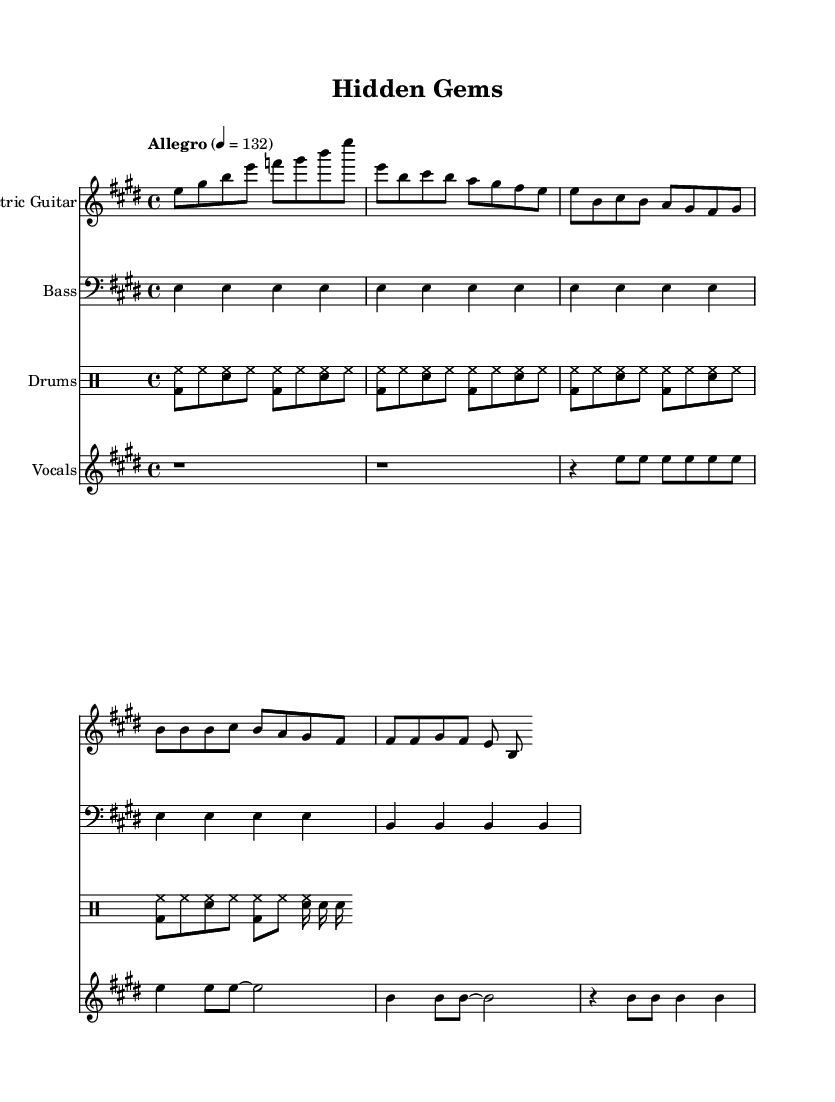What is the key signature of this music? The key signature is E major, which has four sharps (F#, C#, G#, D#). This is indicated at the beginning of the staff in the key signature section.
Answer: E major What is the time signature of this music? The time signature is 4/4, which is indicated at the beginning of the music. This means there are four beats per measure and the quarter note gets one beat.
Answer: 4/4 What is the tempo marking for this piece? The tempo marking is "Allegro" with a tempo of quarter note = 132, which indicates a fast and lively pace. This is clearly stated above the staff.
Answer: Allegro, 132 How many measures are in the chorus section? The chorus section consists of four measures, as indicated by the group of notes and the structure provided for the chorus. Each line of the chorus is organized into one measure, totaling four.
Answer: 4 Which instrument has the introduction in this piece? The instrument that has the introduction is the electric guitar, which plays the first set of notes before the verse begins. The introduction is clearly marked at the start of the guitar staff.
Answer: Electric guitar What type of drum pattern is used throughout the piece? The drum pattern used is a basic rock pattern, which is characterized by a steady kick drum and snare playing, typical for rock music. This can be observed by looking at the drumming notation.
Answer: Basic rock pattern What is the lyrical theme of the song? The lyrical theme is about discovering hidden potential and raw talent, as reflected in the verses and chorus lyrics provided which emphasize looking for gems waiting to shine.
Answer: Hidden potential 